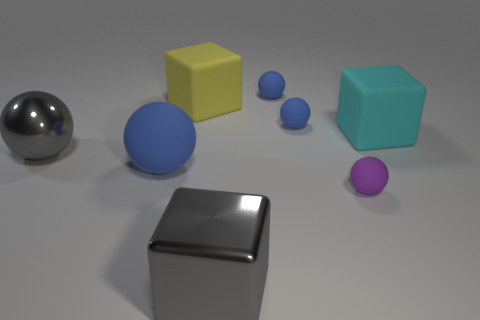There is a large matte object on the right side of the object that is behind the big yellow object that is behind the large gray sphere; what is its shape?
Provide a succinct answer. Cube. There is a big thing that is behind the large cyan matte cube; is it the same shape as the metallic object that is in front of the large blue sphere?
Your answer should be compact. Yes. Are there any other things that are the same size as the purple matte sphere?
Give a very brief answer. Yes. What number of spheres are small brown objects or large metallic things?
Give a very brief answer. 1. Is the large gray block made of the same material as the large cyan object?
Ensure brevity in your answer.  No. How many other objects are there of the same color as the big metal block?
Your answer should be compact. 1. There is a big gray thing that is behind the small purple sphere; what shape is it?
Your response must be concise. Sphere. What number of things are either big metallic cylinders or purple objects?
Give a very brief answer. 1. Do the metallic sphere and the metal thing that is right of the big yellow object have the same size?
Give a very brief answer. Yes. What number of other things are there of the same material as the big gray block
Ensure brevity in your answer.  1. 